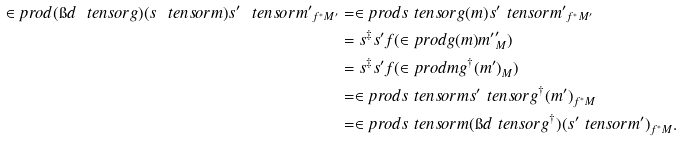<formula> <loc_0><loc_0><loc_500><loc_500>\in p r o d { ( \i d \ t e n s o r g ) ( s \ t e n s o r m ) } { s ^ { \prime } \ t e n s o r m ^ { \prime } } _ { f ^ { * } M ^ { \prime } } & = \in p r o d { s \ t e n s o r g ( m ) } { s ^ { \prime } \ t e n s o r m ^ { \prime } } _ { f ^ { * } M ^ { \prime } } \\ & = s ^ { \ddag } s ^ { \prime } f ( \in p r o d { g ( m ) } { m ^ { \prime } } _ { M } ^ { \prime } ) \\ & = s ^ { \ddag } s ^ { \prime } f ( \in p r o d { m } { g ^ { \dag } ( m ^ { \prime } ) } _ { M } ) \\ & = \in p r o d { s \ t e n s o r m } { s ^ { \prime } \ t e n s o r g ^ { \dag } ( m ^ { \prime } ) } _ { f ^ { * } M } \\ & = \in p r o d { s \ t e n s o r m } { ( \i d \ t e n s o r g ^ { \dag } ) ( s ^ { \prime } \ t e n s o r m ^ { \prime } ) } _ { f ^ { * } M } .</formula> 